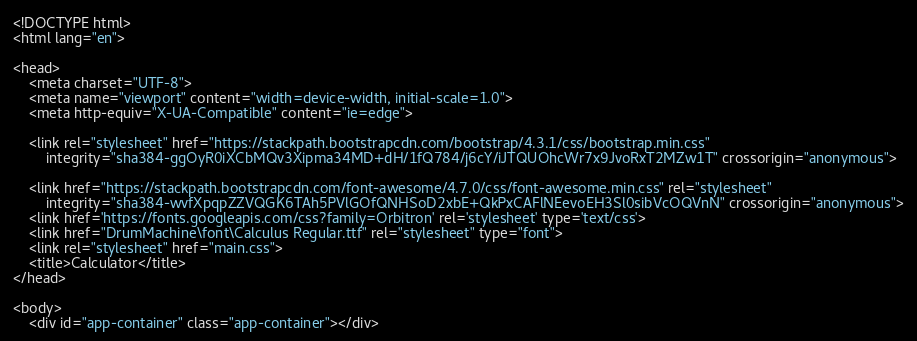Convert code to text. <code><loc_0><loc_0><loc_500><loc_500><_HTML_><!DOCTYPE html>
<html lang="en">

<head>
    <meta charset="UTF-8">
    <meta name="viewport" content="width=device-width, initial-scale=1.0">
    <meta http-equiv="X-UA-Compatible" content="ie=edge">

    <link rel="stylesheet" href="https://stackpath.bootstrapcdn.com/bootstrap/4.3.1/css/bootstrap.min.css"
        integrity="sha384-ggOyR0iXCbMQv3Xipma34MD+dH/1fQ784/j6cY/iJTQUOhcWr7x9JvoRxT2MZw1T" crossorigin="anonymous">

    <link href="https://stackpath.bootstrapcdn.com/font-awesome/4.7.0/css/font-awesome.min.css" rel="stylesheet"
        integrity="sha384-wvfXpqpZZVQGK6TAh5PVlGOfQNHSoD2xbE+QkPxCAFlNEevoEH3Sl0sibVcOQVnN" crossorigin="anonymous">
    <link href='https://fonts.googleapis.com/css?family=Orbitron' rel='stylesheet' type='text/css'>
    <link href="DrumMachine\font\Calculus Regular.ttf" rel="stylesheet" type="font">
    <link rel="stylesheet" href="main.css">
    <title>Calculator</title>
</head>

<body>
    <div id="app-container" class="app-container"></div></code> 